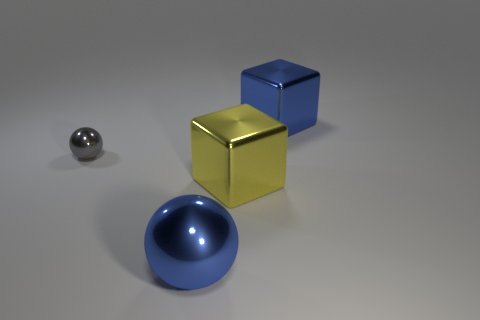Add 1 brown rubber balls. How many objects exist? 5 Add 4 blue metallic blocks. How many blue metallic blocks exist? 5 Subtract 0 red cylinders. How many objects are left? 4 Subtract all small gray metallic balls. Subtract all small metal balls. How many objects are left? 2 Add 4 blue metal balls. How many blue metal balls are left? 5 